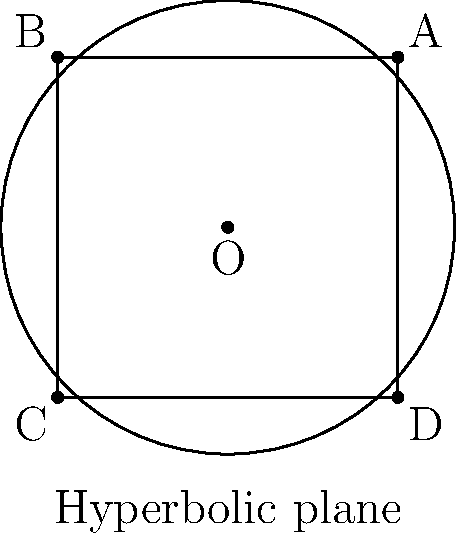In the Beltrami-Klein model of hyperbolic geometry shown above, a square ABCD is inscribed in the circular boundary. If the distance between opposite vertices (e.g., AC) in hyperbolic space is $d$, what is the hyperbolic area of the square in terms of $d$? To solve this problem, we'll follow these steps:

1) In the Beltrami-Klein model, the circular boundary represents infinity in hyperbolic space.

2) The diagonals of the square (AC and BD) are chords of the circle, and their hyperbolic length is given by:

   $d = \ln\left(\frac{1+\sqrt{1-r^2}}{1-\sqrt{1-r^2}}\right)$

   where $r$ is the Euclidean length of the chord relative to the circle's diameter.

3) In this case, $r = \sqrt{2}$ (diagonal of a unit square).

4) The hyperbolic area of a triangle in the Beltrami-Klein model is given by:

   $A = \pi - (\alpha + \beta + \gamma)$

   where $\alpha$, $\beta$, and $\gamma$ are the angles of the triangle in Euclidean space.

5) The square can be divided into four congruent right triangles. Each has two angles of 45° and one right angle (90°).

6) The area of one such triangle is:

   $A_{\triangle} = \pi - (45° + 45° + 90°) = \pi - 180° = \pi - \pi = 0$

7) Therefore, the area of the entire square is:

   $A_{\square} = 4 \cdot A_{\triangle} = 4 \cdot 0 = 0$

8) This result is independent of $d$, which might seem counterintuitive, but it's a consequence of the properties of hyperbolic geometry in this model.
Answer: 0 